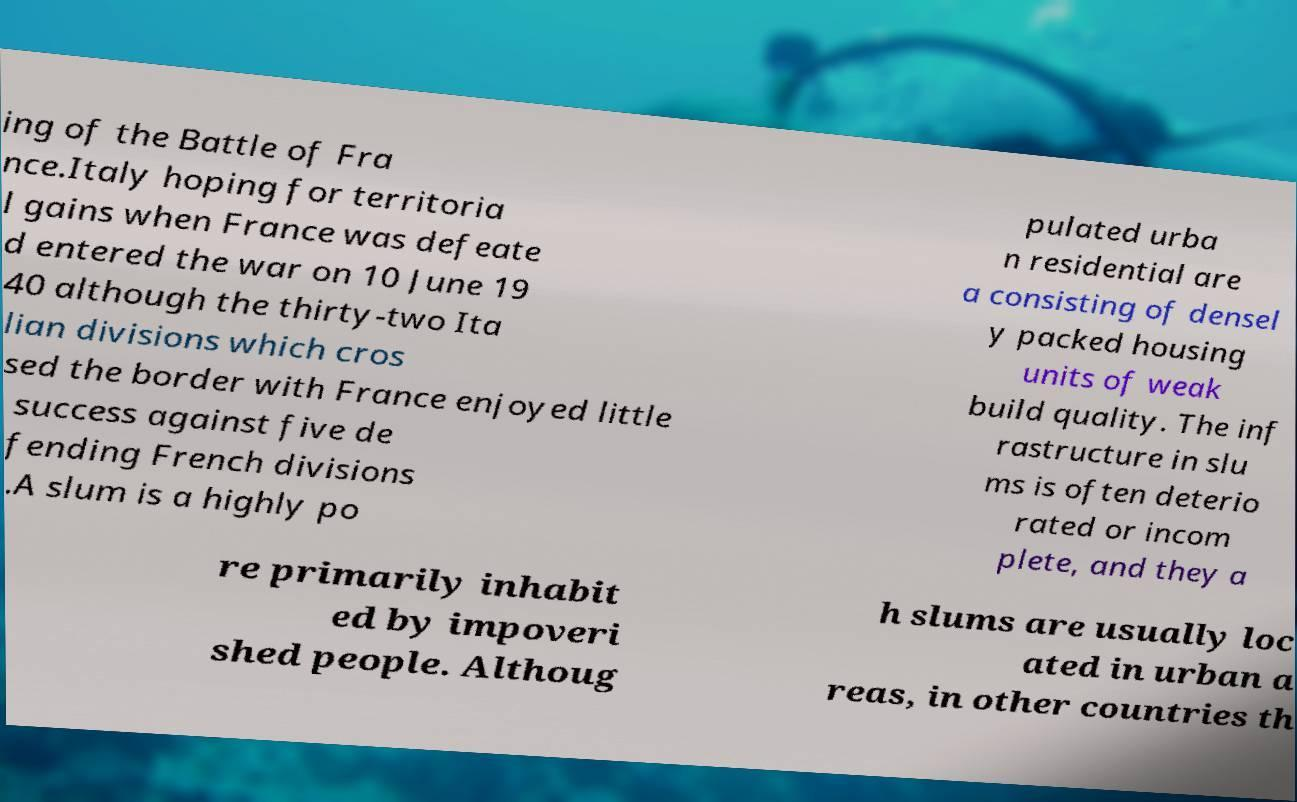Can you read and provide the text displayed in the image?This photo seems to have some interesting text. Can you extract and type it out for me? ing of the Battle of Fra nce.Italy hoping for territoria l gains when France was defeate d entered the war on 10 June 19 40 although the thirty-two Ita lian divisions which cros sed the border with France enjoyed little success against five de fending French divisions .A slum is a highly po pulated urba n residential are a consisting of densel y packed housing units of weak build quality. The inf rastructure in slu ms is often deterio rated or incom plete, and they a re primarily inhabit ed by impoveri shed people. Althoug h slums are usually loc ated in urban a reas, in other countries th 